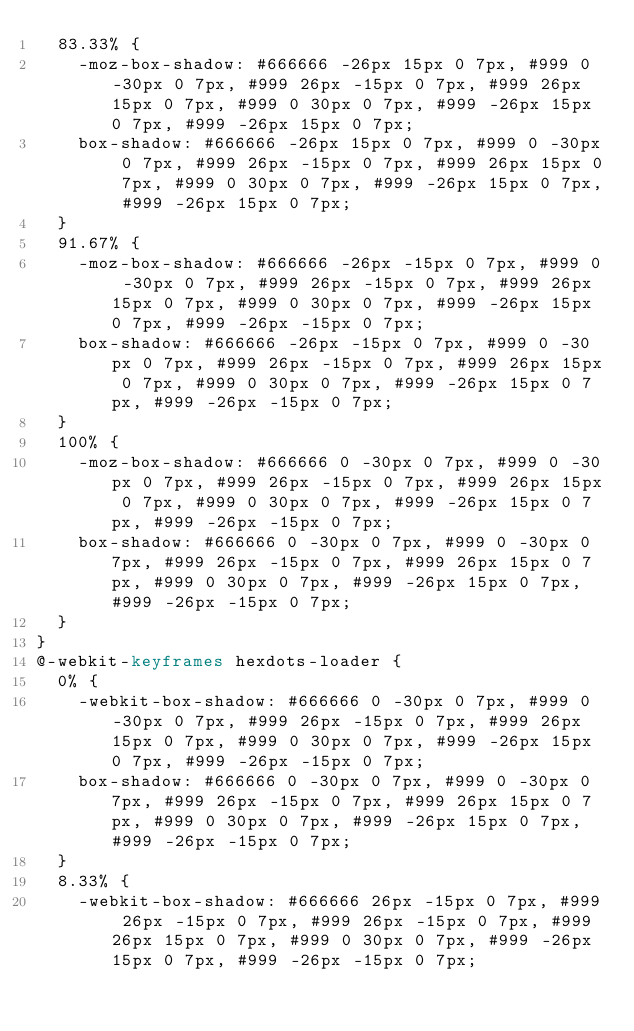<code> <loc_0><loc_0><loc_500><loc_500><_CSS_>  83.33% {
    -moz-box-shadow: #666666 -26px 15px 0 7px, #999 0 -30px 0 7px, #999 26px -15px 0 7px, #999 26px 15px 0 7px, #999 0 30px 0 7px, #999 -26px 15px 0 7px, #999 -26px 15px 0 7px;
    box-shadow: #666666 -26px 15px 0 7px, #999 0 -30px 0 7px, #999 26px -15px 0 7px, #999 26px 15px 0 7px, #999 0 30px 0 7px, #999 -26px 15px 0 7px, #999 -26px 15px 0 7px;
  }
  91.67% {
    -moz-box-shadow: #666666 -26px -15px 0 7px, #999 0 -30px 0 7px, #999 26px -15px 0 7px, #999 26px 15px 0 7px, #999 0 30px 0 7px, #999 -26px 15px 0 7px, #999 -26px -15px 0 7px;
    box-shadow: #666666 -26px -15px 0 7px, #999 0 -30px 0 7px, #999 26px -15px 0 7px, #999 26px 15px 0 7px, #999 0 30px 0 7px, #999 -26px 15px 0 7px, #999 -26px -15px 0 7px;
  }
  100% {
    -moz-box-shadow: #666666 0 -30px 0 7px, #999 0 -30px 0 7px, #999 26px -15px 0 7px, #999 26px 15px 0 7px, #999 0 30px 0 7px, #999 -26px 15px 0 7px, #999 -26px -15px 0 7px;
    box-shadow: #666666 0 -30px 0 7px, #999 0 -30px 0 7px, #999 26px -15px 0 7px, #999 26px 15px 0 7px, #999 0 30px 0 7px, #999 -26px 15px 0 7px, #999 -26px -15px 0 7px;
  }
}
@-webkit-keyframes hexdots-loader {
  0% {
    -webkit-box-shadow: #666666 0 -30px 0 7px, #999 0 -30px 0 7px, #999 26px -15px 0 7px, #999 26px 15px 0 7px, #999 0 30px 0 7px, #999 -26px 15px 0 7px, #999 -26px -15px 0 7px;
    box-shadow: #666666 0 -30px 0 7px, #999 0 -30px 0 7px, #999 26px -15px 0 7px, #999 26px 15px 0 7px, #999 0 30px 0 7px, #999 -26px 15px 0 7px, #999 -26px -15px 0 7px;
  }
  8.33% {
    -webkit-box-shadow: #666666 26px -15px 0 7px, #999 26px -15px 0 7px, #999 26px -15px 0 7px, #999 26px 15px 0 7px, #999 0 30px 0 7px, #999 -26px 15px 0 7px, #999 -26px -15px 0 7px;</code> 